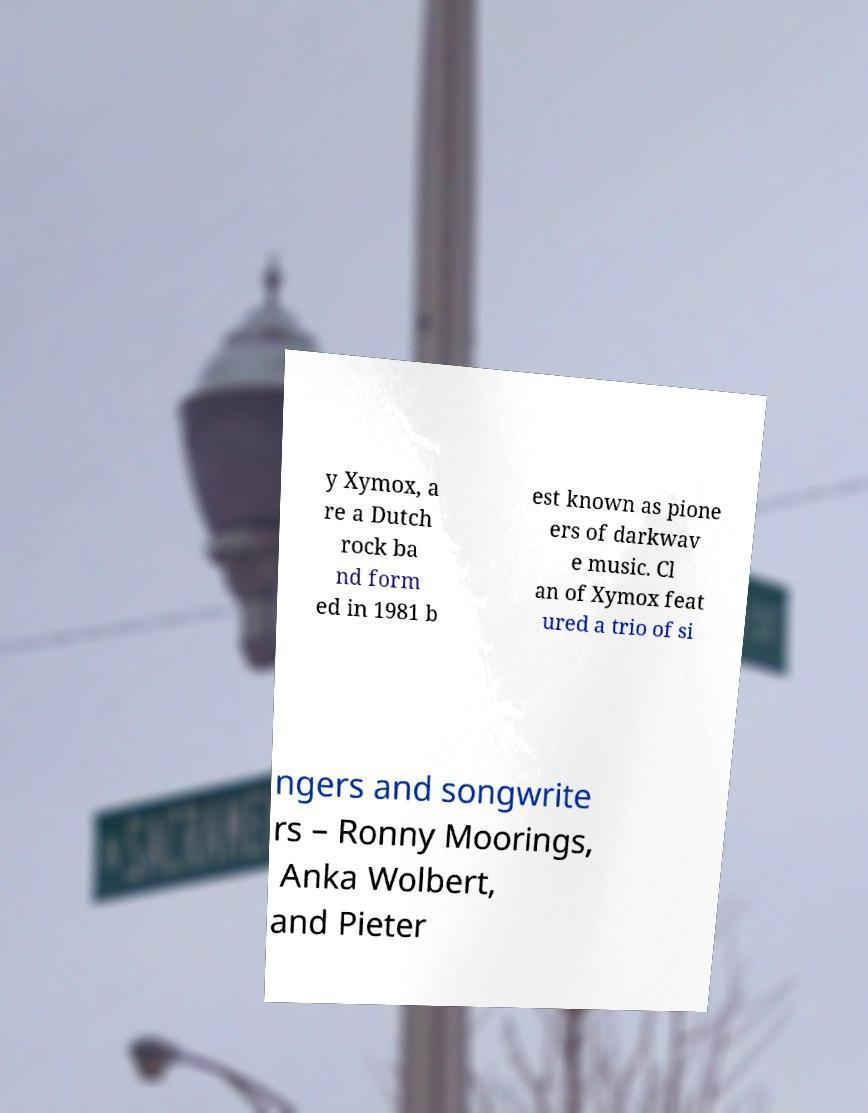Can you accurately transcribe the text from the provided image for me? y Xymox, a re a Dutch rock ba nd form ed in 1981 b est known as pione ers of darkwav e music. Cl an of Xymox feat ured a trio of si ngers and songwrite rs – Ronny Moorings, Anka Wolbert, and Pieter 